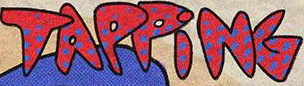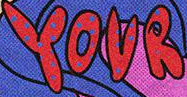What text appears in these images from left to right, separated by a semicolon? TAPPiNG; YOUR 